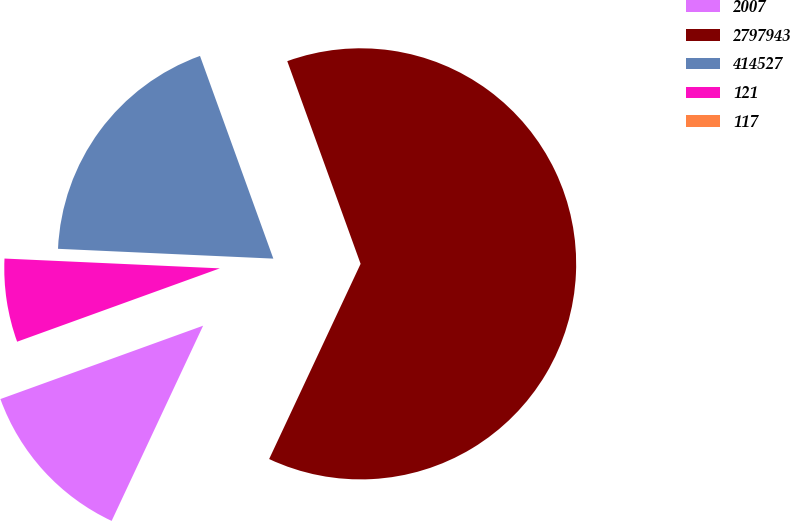Convert chart to OTSL. <chart><loc_0><loc_0><loc_500><loc_500><pie_chart><fcel>2007<fcel>2797943<fcel>414527<fcel>121<fcel>117<nl><fcel>12.5%<fcel>62.5%<fcel>18.75%<fcel>6.25%<fcel>0.0%<nl></chart> 